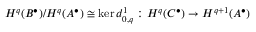<formula> <loc_0><loc_0><loc_500><loc_500>H ^ { q } ( B ^ { \bullet } ) / H ^ { q } ( A ^ { \bullet } ) \cong \ker d _ { 0 , q } ^ { 1 } \colon H ^ { q } ( C ^ { \bullet } ) \rightarrow H ^ { q + 1 } ( A ^ { \bullet } )</formula> 